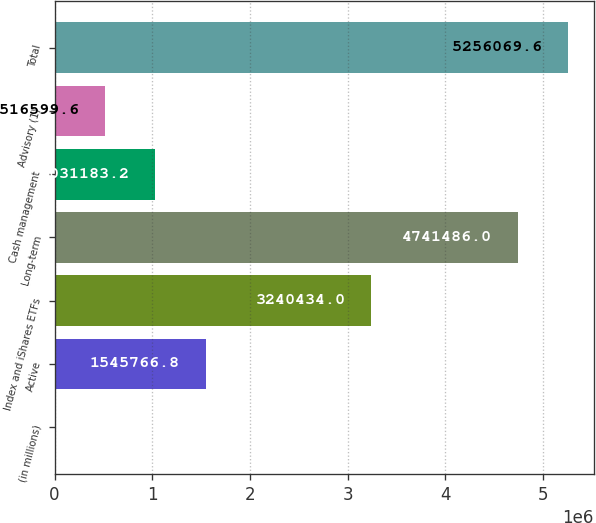Convert chart. <chart><loc_0><loc_0><loc_500><loc_500><bar_chart><fcel>(in millions)<fcel>Active<fcel>Index and iShares ETFs<fcel>Long-term<fcel>Cash management<fcel>Advisory (1)<fcel>Total<nl><fcel>2016<fcel>1.54577e+06<fcel>3.24043e+06<fcel>4.74149e+06<fcel>1.03118e+06<fcel>516600<fcel>5.25607e+06<nl></chart> 